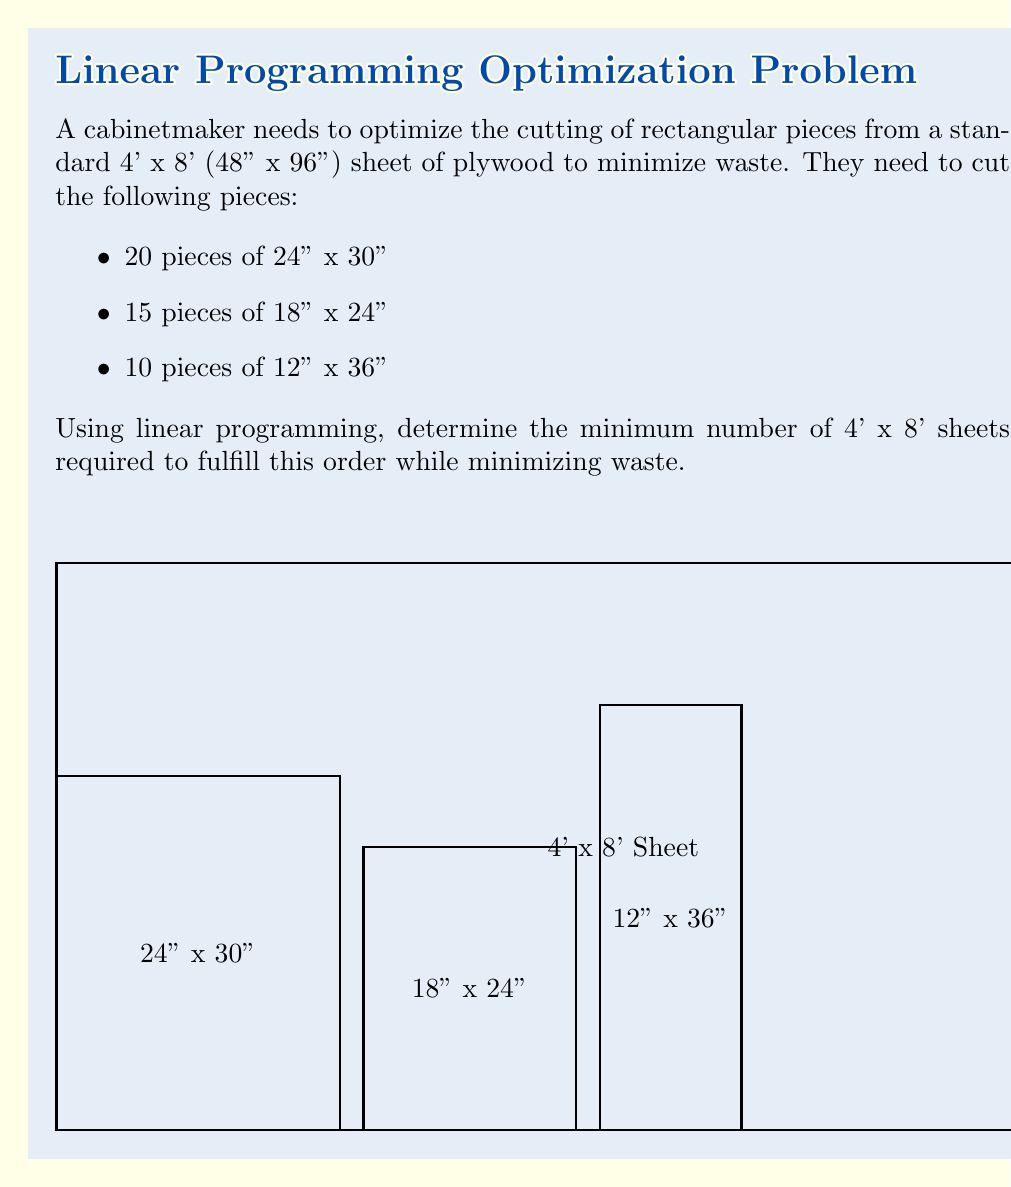Help me with this question. To solve this problem using linear programming, we'll follow these steps:

1) Define variables:
   Let $x$ = number of 4' x 8' sheets

2) Set up constraints:
   Each sheet can fit different combinations of the required pieces. We need to determine these combinations.

   a) 24" x 30" pieces: 
      Horizontally: 96 ÷ 24 = 4 pieces
      Vertically: 48 ÷ 30 = 1 piece
      Total per sheet: 4 * 1 = 4 pieces

   b) 18" x 24" pieces:
      Horizontally: 96 ÷ 18 = 5 pieces
      Vertically: 48 ÷ 24 = 2 pieces
      Total per sheet: 5 * 2 = 10 pieces

   c) 12" x 36" pieces:
      Horizontally: 96 ÷ 12 = 8 pieces
      Vertically: 48 ÷ 36 = 1 piece
      Total per sheet: 8 * 1 = 8 pieces

3) Formulate constraints:
   $$4x \geq 20$$ (for 24" x 30" pieces)
   $$10x \geq 15$$ (for 18" x 24" pieces)
   $$8x \geq 10$$ (for 12" x 36" pieces)

4) Objective function:
   Minimize $z = x$

5) Solve the system:
   From the constraints:
   $x \geq 5$ (from 24" x 30" pieces)
   $x \geq 1.5$ (from 18" x 24" pieces)
   $x \geq 1.25$ (from 12" x 36" pieces)

   The binding constraint is $x \geq 5$

Therefore, the minimum number of sheets required is 5.
Answer: 5 sheets 